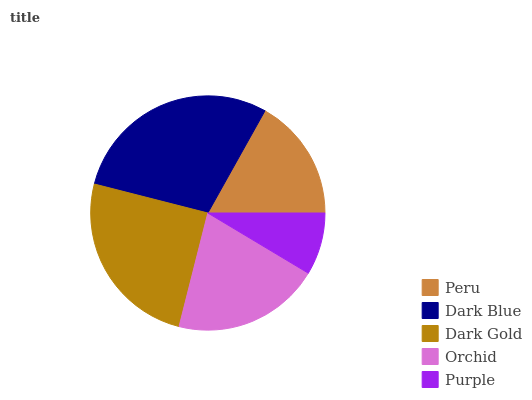Is Purple the minimum?
Answer yes or no. Yes. Is Dark Blue the maximum?
Answer yes or no. Yes. Is Dark Gold the minimum?
Answer yes or no. No. Is Dark Gold the maximum?
Answer yes or no. No. Is Dark Blue greater than Dark Gold?
Answer yes or no. Yes. Is Dark Gold less than Dark Blue?
Answer yes or no. Yes. Is Dark Gold greater than Dark Blue?
Answer yes or no. No. Is Dark Blue less than Dark Gold?
Answer yes or no. No. Is Orchid the high median?
Answer yes or no. Yes. Is Orchid the low median?
Answer yes or no. Yes. Is Purple the high median?
Answer yes or no. No. Is Peru the low median?
Answer yes or no. No. 